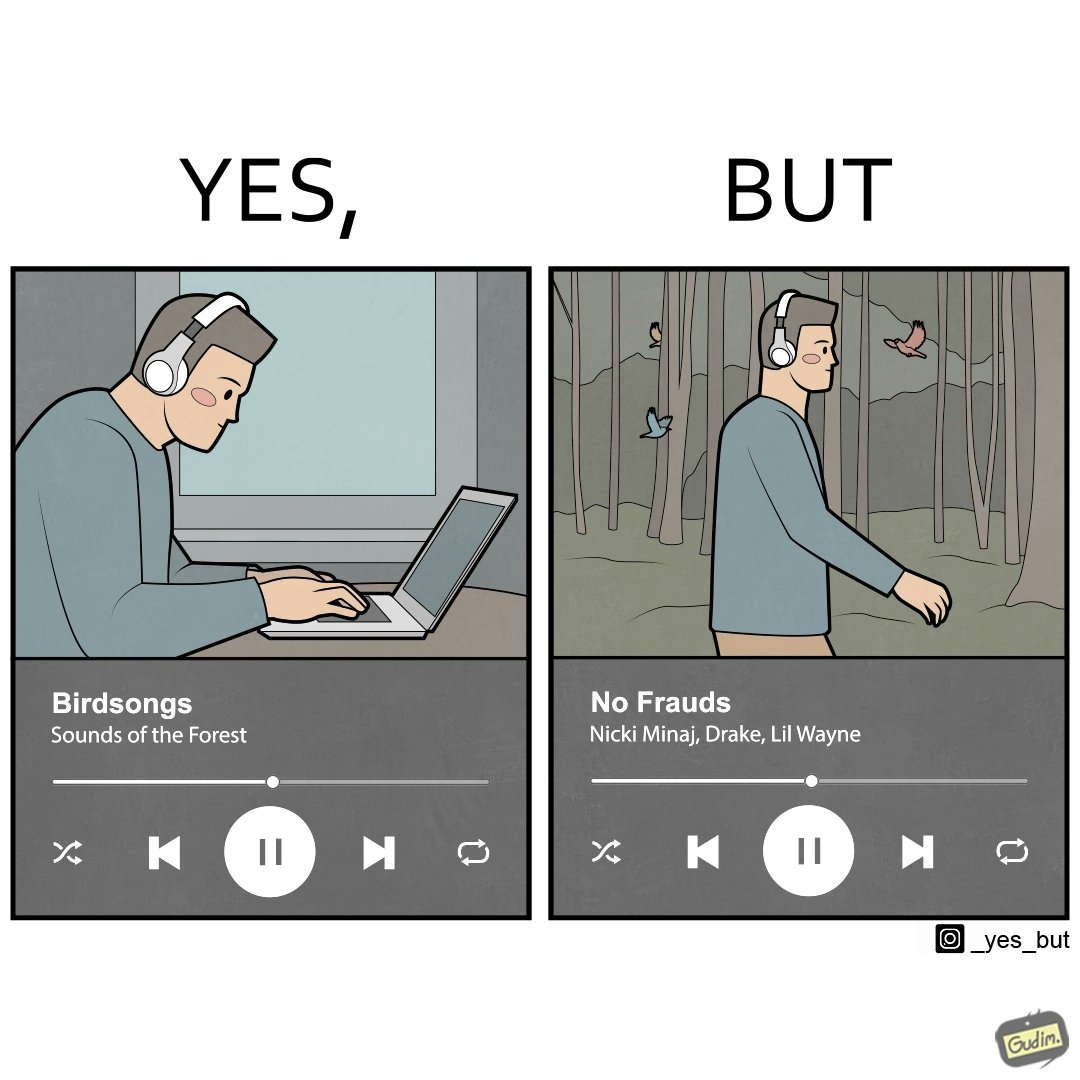Does this image contain satire or humor? Yes, this image is satirical. 